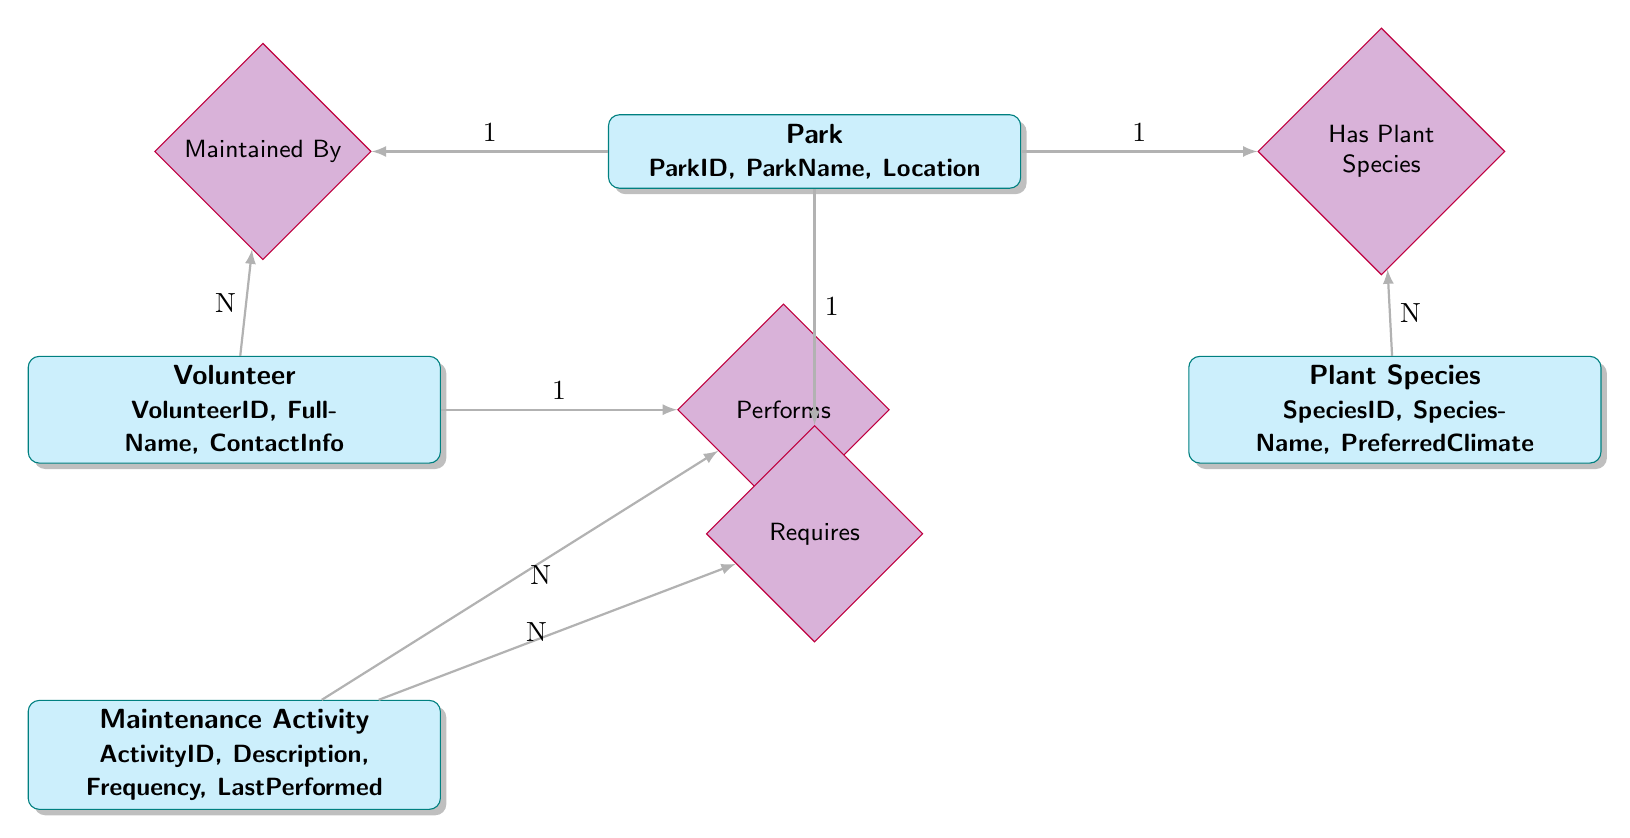What entities are represented in the diagram? The diagram includes four entities: Park, Plant Species, Volunteer, and Maintenance Activity.
Answer: Park, Plant Species, Volunteer, Maintenance Activity What relationship exists between Park and Plant Species? The diagram shows that the Park has Plant Species, indicating a connection where parks include various plant species.
Answer: Has Plant Species How many attributes does the Volunteer entity have? The Volunteer entity is represented with three attributes: VolunteerID, FullName, and ContactInfo.
Answer: 3 What is the maximum number of plant species that can be associated with a park? The relationship labeled "Has Plant Species" indicates that each park (1) can have multiple plant species (N). Thus, while there is one instance of a park, it can have many plant species associated with it.
Answer: N Who performs the maintenance activities for the parks? The diagram indicates that the Volunteers perform maintenance activities, connecting them directly to the Maintenance Activity entity.
Answer: Volunteer What does the "Requires" relationship signify in the diagram? The "Requires" relationship indicates that each Park has multiple Maintenance Activities that it needs, showing the maintenance needs of the parks.
Answer: Each Park requires multiple activities How many volunteers can maintain a single park? According to the "Maintained By" relationship, a single park can be maintained by multiple volunteers, indicating a many-to-one relationship.
Answer: N What is the significance of the frequency attribute in the Maintenance Activity? The frequency attribute provides information on how often the maintenance activities are performed, indicating the regularity of upkeep required for the parks.
Answer: Frequency What is the connection between the Volunteer and Maintenance Activity entities? The Volunteer can perform multiple Maintenance Activities, illustrated by the "Performs" relationship, indicating that volunteers have several tasks they undertake in maintaining the parks.
Answer: Performs 